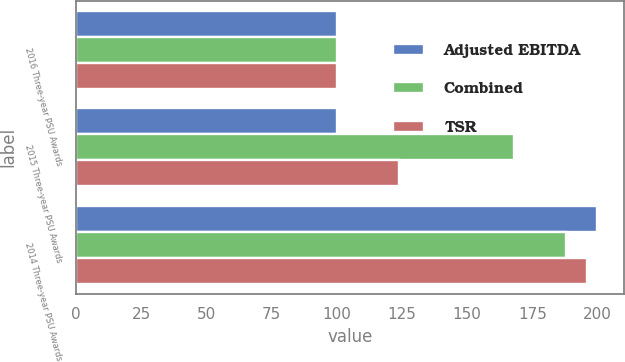<chart> <loc_0><loc_0><loc_500><loc_500><stacked_bar_chart><ecel><fcel>2016 Three-year PSU Awards<fcel>2015 Three-year PSU Awards<fcel>2014 Three-year PSU Awards<nl><fcel>Adjusted EBITDA<fcel>100<fcel>100<fcel>200<nl><fcel>Combined<fcel>100<fcel>168<fcel>188<nl><fcel>TSR<fcel>100<fcel>124<fcel>196<nl></chart> 